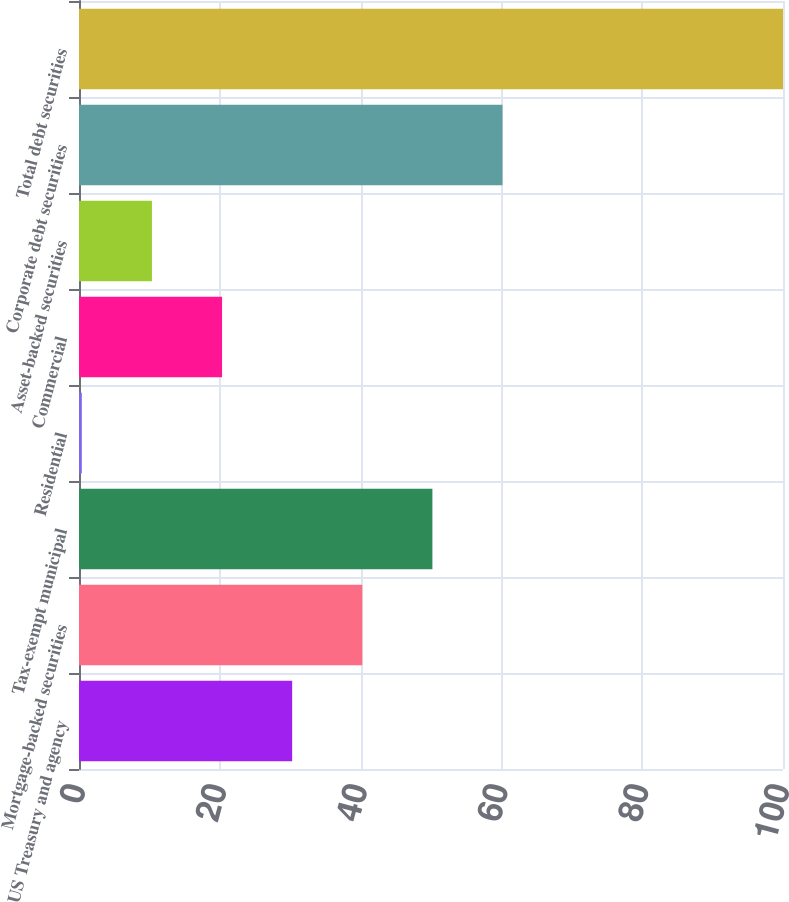<chart> <loc_0><loc_0><loc_500><loc_500><bar_chart><fcel>US Treasury and agency<fcel>Mortgage-backed securities<fcel>Tax-exempt municipal<fcel>Residential<fcel>Commercial<fcel>Asset-backed securities<fcel>Corporate debt securities<fcel>Total debt securities<nl><fcel>30.28<fcel>40.24<fcel>50.2<fcel>0.4<fcel>20.32<fcel>10.36<fcel>60.16<fcel>100<nl></chart> 